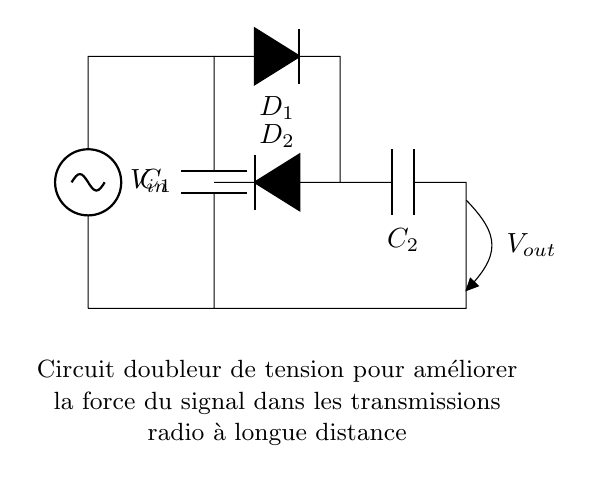What is the main function of this circuit? The main function is to double the input voltage, allowing for improved signal strength in long-distance radio transmissions. This is shown as a voltage doubler circuit, which is designed to increase the available output voltage from the input source.
Answer: Double voltage What is the value of the first capacitor? The first capacitor in the circuit is labeled as C1, and while no specific value is given in the diagram, it is a critical component for the voltage doubling function. Capacitors store energy and help smooth the output voltage.
Answer: C1 How many diodes are present in the circuit? The circuit contains two diodes, labeled D1 and D2, which are used in the rectification process to convert AC to DC and facilitate the voltage doubling.
Answer: Two Where does the output voltage come from? The output voltage, labeled Vout, is taken across the second capacitor, C2, which stores the doubled voltage after the rectification process. It is crucial for the functionality of this voltage doubler circuit.
Answer: C2 What happens to the signal strength when using this circuit? The signal strength is improved because the voltage doubler circuit increases the output voltage, which can enhance the transmission distance and clarity for long-distance radio communications.
Answer: Improved signal strength Explain the role of D1 and D2 in the circuit. The diodes D1 and D2 serve as rectifiers, allowing current to flow in one direction while blocking it in the opposite direction. They work together with the capacitors to create a DC voltage from the AC input, effectively doubling the output voltage. This rectification is crucial for maintaining a consistent voltage supply for radio transmissions.
Answer: Rectifiers 